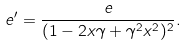Convert formula to latex. <formula><loc_0><loc_0><loc_500><loc_500>e ^ { \prime } = \frac { e } { ( 1 - 2 x \gamma + \gamma ^ { 2 } x ^ { 2 } ) ^ { 2 } } .</formula> 